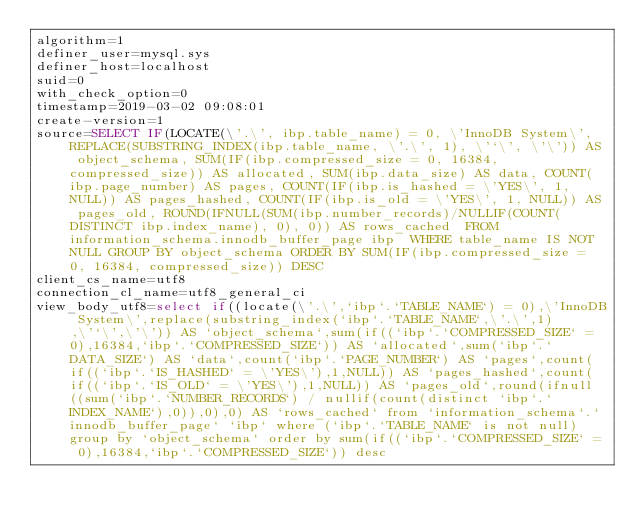<code> <loc_0><loc_0><loc_500><loc_500><_VisualBasic_>algorithm=1
definer_user=mysql.sys
definer_host=localhost
suid=0
with_check_option=0
timestamp=2019-03-02 09:08:01
create-version=1
source=SELECT IF(LOCATE(\'.\', ibp.table_name) = 0, \'InnoDB System\', REPLACE(SUBSTRING_INDEX(ibp.table_name, \'.\', 1), \'`\', \'\')) AS object_schema, SUM(IF(ibp.compressed_size = 0, 16384, compressed_size)) AS allocated, SUM(ibp.data_size) AS data, COUNT(ibp.page_number) AS pages, COUNT(IF(ibp.is_hashed = \'YES\', 1, NULL)) AS pages_hashed, COUNT(IF(ibp.is_old = \'YES\', 1, NULL)) AS pages_old, ROUND(IFNULL(SUM(ibp.number_records)/NULLIF(COUNT(DISTINCT ibp.index_name), 0), 0)) AS rows_cached  FROM information_schema.innodb_buffer_page ibp  WHERE table_name IS NOT NULL GROUP BY object_schema ORDER BY SUM(IF(ibp.compressed_size = 0, 16384, compressed_size)) DESC
client_cs_name=utf8
connection_cl_name=utf8_general_ci
view_body_utf8=select if((locate(\'.\',`ibp`.`TABLE_NAME`) = 0),\'InnoDB System\',replace(substring_index(`ibp`.`TABLE_NAME`,\'.\',1),\'`\',\'\')) AS `object_schema`,sum(if((`ibp`.`COMPRESSED_SIZE` = 0),16384,`ibp`.`COMPRESSED_SIZE`)) AS `allocated`,sum(`ibp`.`DATA_SIZE`) AS `data`,count(`ibp`.`PAGE_NUMBER`) AS `pages`,count(if((`ibp`.`IS_HASHED` = \'YES\'),1,NULL)) AS `pages_hashed`,count(if((`ibp`.`IS_OLD` = \'YES\'),1,NULL)) AS `pages_old`,round(ifnull((sum(`ibp`.`NUMBER_RECORDS`) / nullif(count(distinct `ibp`.`INDEX_NAME`),0)),0),0) AS `rows_cached` from `information_schema`.`innodb_buffer_page` `ibp` where (`ibp`.`TABLE_NAME` is not null) group by `object_schema` order by sum(if((`ibp`.`COMPRESSED_SIZE` = 0),16384,`ibp`.`COMPRESSED_SIZE`)) desc
</code> 